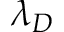Convert formula to latex. <formula><loc_0><loc_0><loc_500><loc_500>\lambda _ { D }</formula> 